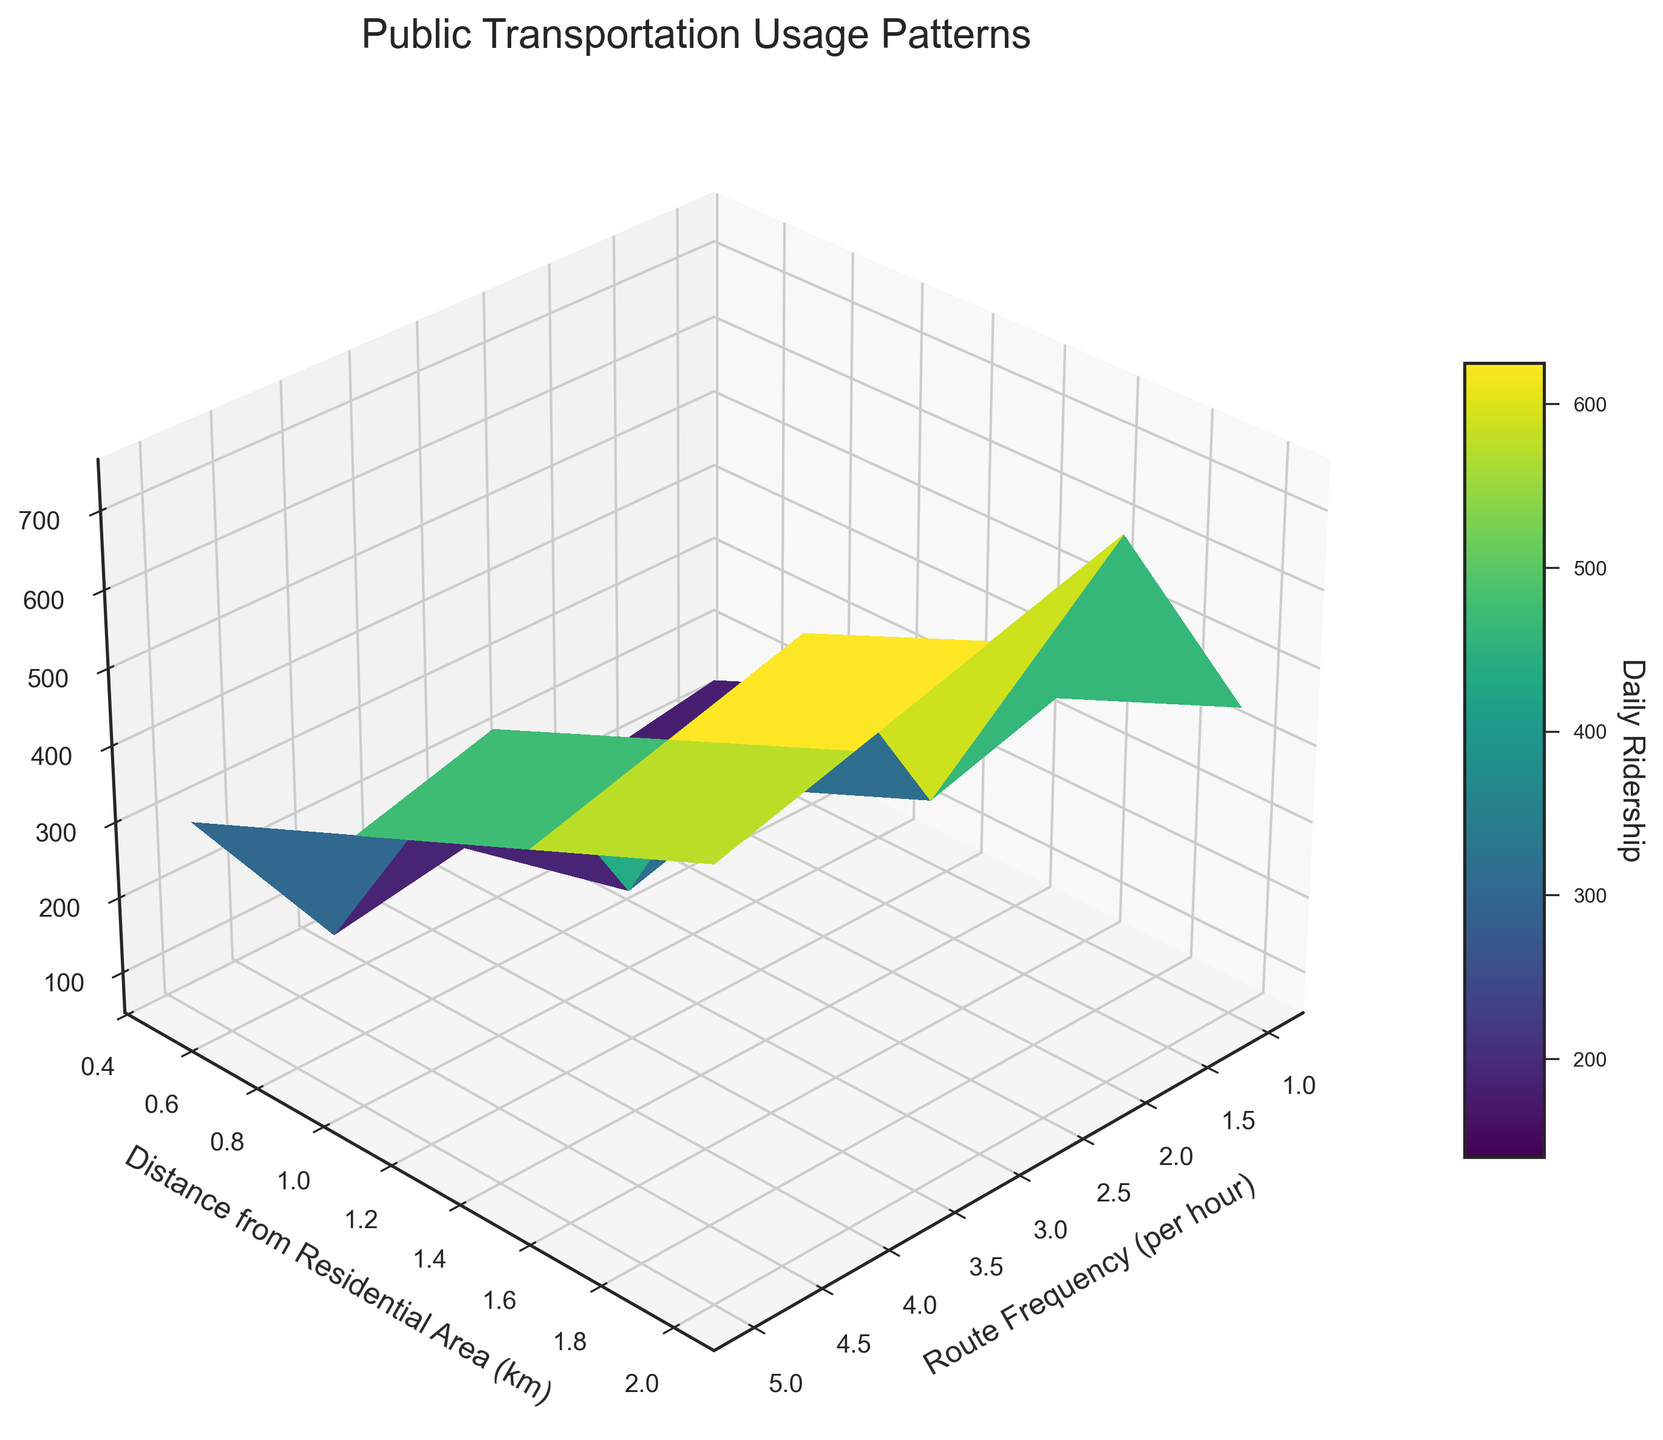What is the title of the figure? The title is usually located at the top-center of the figure and gives an idea of what the plot represents.
Answer: Public Transportation Usage Patterns What is the range of Route Frequency values plotted in the figure? The X-axis represents Route Frequency values. By observing the axis, one can see that it ranges from 1 to 5 per hour.
Answer: 1 to 5 per hour How does the Daily Ridership change as the Distance from Residential Area increases for a Route Frequency of 3 per hour? Locate the line/section of the surface plot where the Route Frequency is 3 per hour on the X-axis and observe the Z-axis values (Daily Ridership) as the Distance from Residential Area increases along the Y-axis. The ridership declines from 450 to 300 as the distance increases from 0.5 to 2.0 km.
Answer: It decreases What is the maximum Daily Ridership value, and at what Route Frequency and Distance does it occur? Scan the surface plot for the highest peak. Identify the corresponding Route Frequency and Distance from Residential Area for this peak. The maximum Daily Ridership value is 750, occurring at a Route Frequency of 5 per hour and a Distance from Residential Area of 0.5 km.
Answer: 750 at Route Frequency 5 per hour and Distance 0.5 km Comparing the Daily Ridership at Route Frequency 4 per hour and Distances of 0.5 km and 2.0 km, what is the difference in ridership? Find the Daily Ridership values on the surface plot for a Route Frequency of 4 per hour at Distances of 0.5 km and 2.0 km. The values are 600 and 450, respectively. The difference is 600 - 450 = 150.
Answer: 150 Does the color gradient of the surface help in identifying areas of high and low ridership? Observe the color gradient on the surface and its corresponding ridership values on the color bar. Darker colors (e.g., dark green) represent lower ridership, while lighter colors (e.g., yellow) represent higher ridership. This gradient visually distinguishes areas of varying ridership.
Answer: Yes How does the Daily Ridership for a Route Frequency of 2 per hour at 1.5 km compare to that of 4 per hour at 1.0 km? Find the Daily Ridership values for a Route Frequency of 2 per hour at 1.5 km and 4 per hour at 1.0 km on the surface plot. The values are 200 and 550, respectively. Comparison shows 4 per hour at 1.0 km has higher ridership.
Answer: 4 per hour at 1.0 km is higher What trend can you observe in Daily Ridership concerning Route Frequency across all distances? Examine the surface plot along the X-axis for changes in Daily Ridership as Route Frequency increases. A general trend shows that higher Route Frequency results in higher Daily Ridership, regardless of the distance.
Answer: Higher Route Frequency results in higher ridership Evaluate the overall impact of proximity to residential areas on public transportation usage. Look at the pattern of ridership values as the Distance from Residential Area increases (moving along the Y-axis). Regardless of Route Frequency, there is a general decrease in Daily Ridership as the Distance from Residential Area increases.
Answer: Decreases ridership Identify the color bar's role in interpreting the Daily Ridership values. The color bar provides a scale for interpreting ridership values based on color. By matching the colors on the surface plot to the color bar, one can determine the approximate ridership values at different points on the plot.
Answer: It assists in determining ridership values 